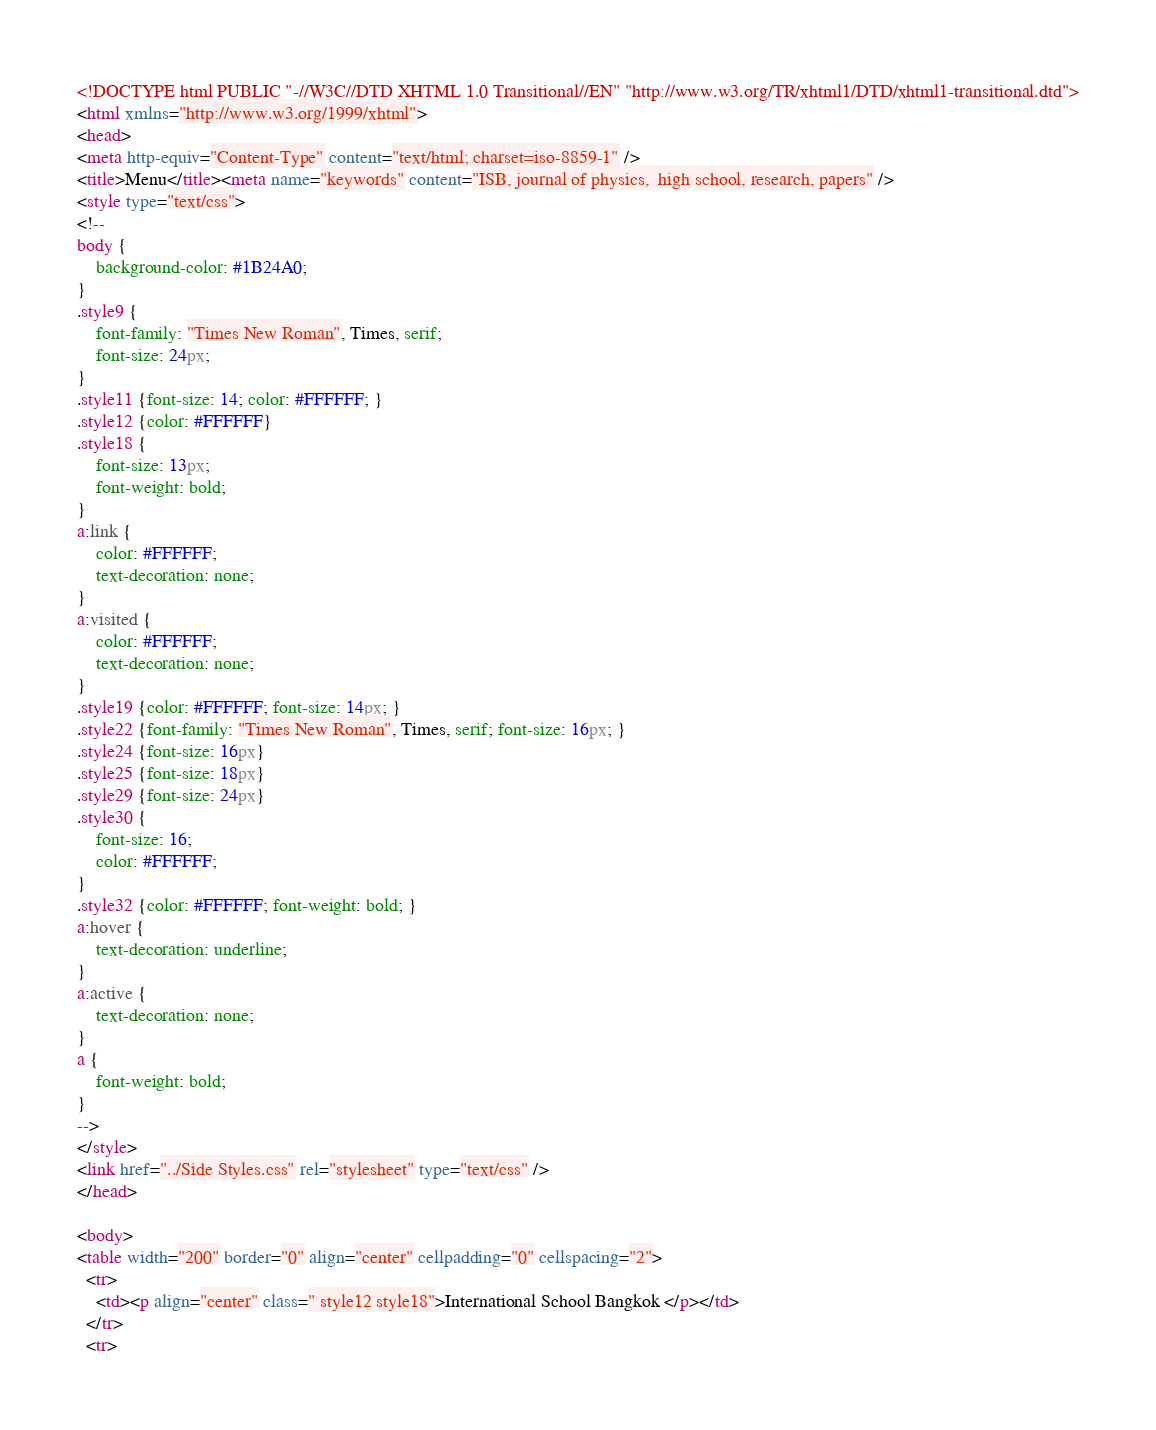<code> <loc_0><loc_0><loc_500><loc_500><_HTML_><!DOCTYPE html PUBLIC "-//W3C//DTD XHTML 1.0 Transitional//EN" "http://www.w3.org/TR/xhtml1/DTD/xhtml1-transitional.dtd">
<html xmlns="http://www.w3.org/1999/xhtml">
<head>
<meta http-equiv="Content-Type" content="text/html; charset=iso-8859-1" />
<title>Menu</title><meta name="keywords" content="ISB, journal of physics,  high school, research, papers" />
<style type="text/css">
<!--
body {
	background-color: #1B24A0;
}
.style9 {
	font-family: "Times New Roman", Times, serif;
	font-size: 24px;
}
.style11 {font-size: 14; color: #FFFFFF; }
.style12 {color: #FFFFFF}
.style18 {
	font-size: 13px;
	font-weight: bold;
}
a:link {
	color: #FFFFFF;
	text-decoration: none;
}
a:visited {
	color: #FFFFFF;
	text-decoration: none;
}
.style19 {color: #FFFFFF; font-size: 14px; }
.style22 {font-family: "Times New Roman", Times, serif; font-size: 16px; }
.style24 {font-size: 16px}
.style25 {font-size: 18px}
.style29 {font-size: 24px}
.style30 {
	font-size: 16;
	color: #FFFFFF;
}
.style32 {color: #FFFFFF; font-weight: bold; }
a:hover {
	text-decoration: underline;
}
a:active {
	text-decoration: none;
}
a {
	font-weight: bold;
}
-->
</style>
<link href="../Side Styles.css" rel="stylesheet" type="text/css" />
</head>

<body>
<table width="200" border="0" align="center" cellpadding="0" cellspacing="2">
  <tr>
    <td><p align="center" class=" style12 style18">International School Bangkok </p></td>
  </tr>
  <tr></code> 